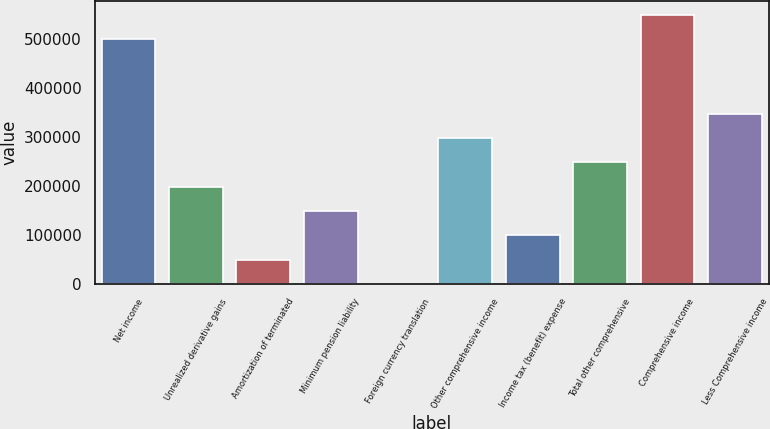Convert chart. <chart><loc_0><loc_0><loc_500><loc_500><bar_chart><fcel>Net income<fcel>Unrealized derivative gains<fcel>Amortization of terminated<fcel>Minimum pension liability<fcel>Foreign currency translation<fcel>Other comprehensive income<fcel>Income tax (benefit) expense<fcel>Total other comprehensive<fcel>Comprehensive income<fcel>Less Comprehensive income<nl><fcel>500073<fcel>198429<fcel>49610<fcel>148823<fcel>3.6<fcel>297642<fcel>99216.5<fcel>248036<fcel>549680<fcel>347249<nl></chart> 